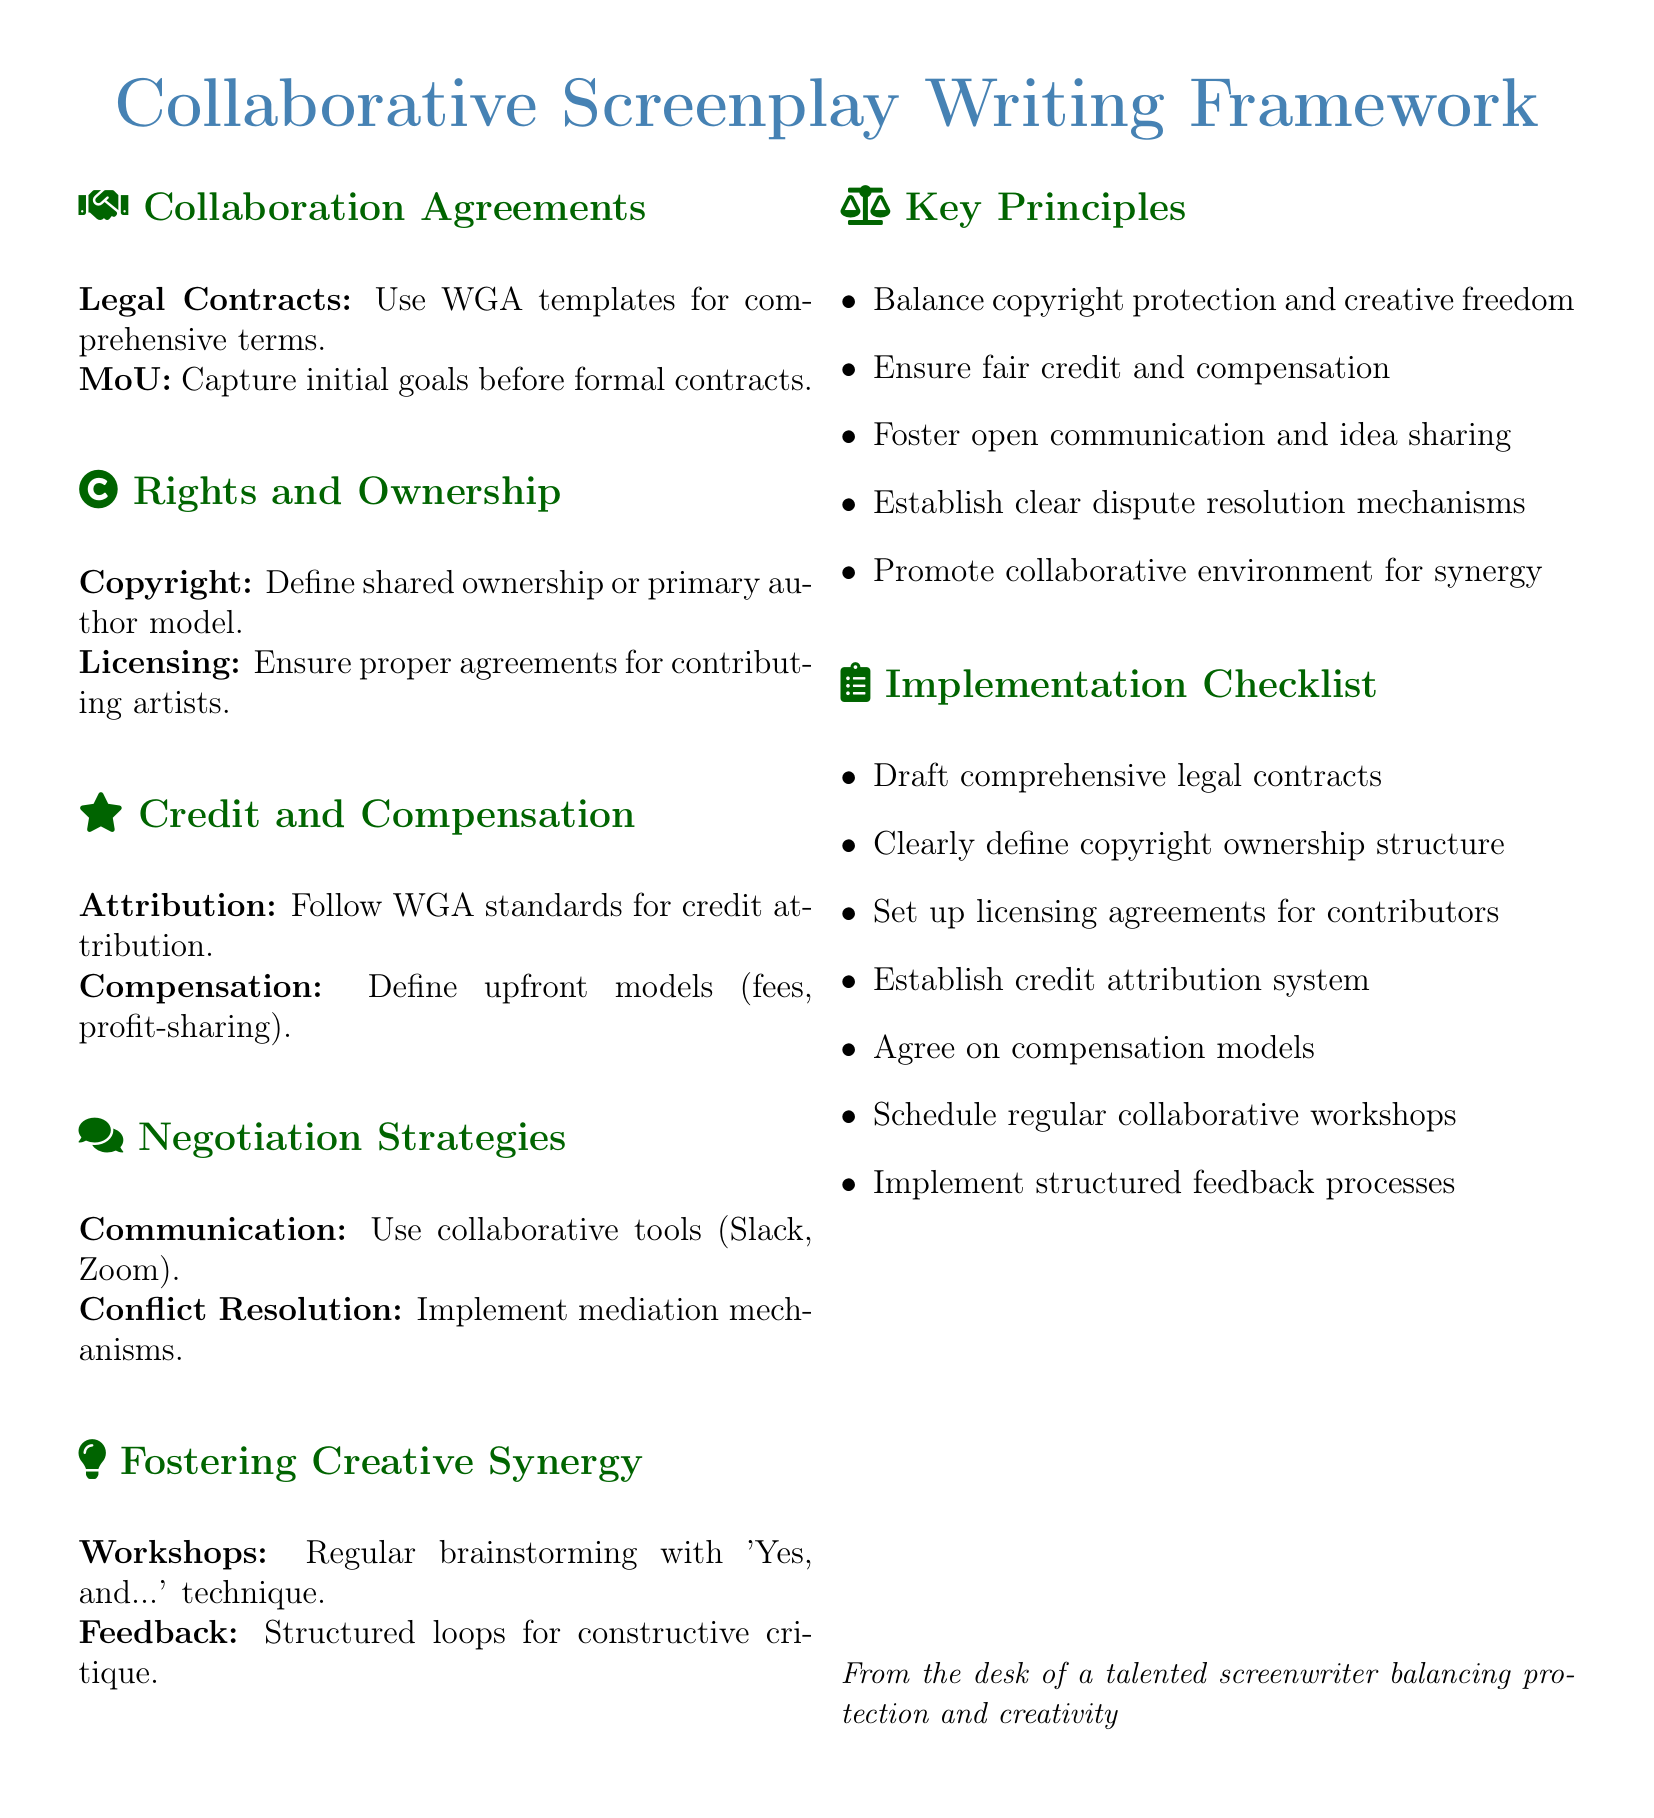What are the collaboration agreements mentioned? The document lists "Legal Contracts" and "MoU" as collaboration agreements under the section titled "Collaboration Agreements."
Answer: Legal Contracts, MoU What does the acronym WGA stand for in the context of the document? The acronym WGA refers to the organization that provides templates for contracts and standards for credit, mentioned multiple times in the document.
Answer: Writers Guild of America What are two key rights and ownership components outlined? The document specifies "Copyright" and "Licensing" as the two components under the "Rights and Ownership" section.
Answer: Copyright, Licensing What strategy is recommended for conflict resolution? The document suggests implementing "mediation mechanisms" for conflict resolution under the "Negotiation Strategies" section.
Answer: Mediation mechanisms How many key principles are mentioned in the document? The section titled "Key Principles" lists five principles that govern collaboration in screenplay writing.
Answer: Five What collaborative tools are suggested for communication? The document mentions "Slack" and "Zoom" as collaborative tools under the "Negotiation Strategies" section.
Answer: Slack, Zoom What method is primarily advocated for fostering creative synergy? The document recommends using "Yes, and..." technique during regular brainstorming sessions for fostering creative synergy.
Answer: Yes, and.. What type of workshops does the document advocate for? The document advocates for "regular collaborative workshops" as part of the implementation checklist.
Answer: Regular collaborative workshops What is the main focus of the implementation checklist? The checklist focuses on practical steps to ensure fair credit, compensation, and creative collaboration among co-writers and artists.
Answer: Practical steps for collaboration 